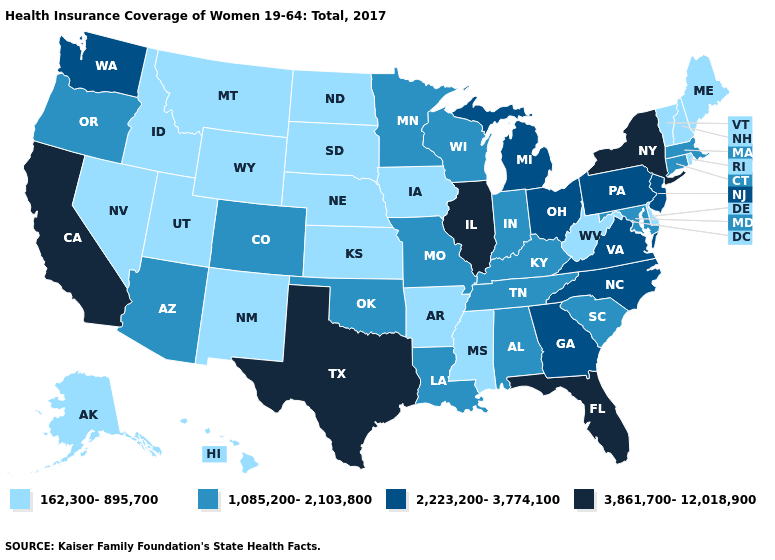What is the value of Iowa?
Give a very brief answer. 162,300-895,700. Name the states that have a value in the range 162,300-895,700?
Keep it brief. Alaska, Arkansas, Delaware, Hawaii, Idaho, Iowa, Kansas, Maine, Mississippi, Montana, Nebraska, Nevada, New Hampshire, New Mexico, North Dakota, Rhode Island, South Dakota, Utah, Vermont, West Virginia, Wyoming. Name the states that have a value in the range 2,223,200-3,774,100?
Be succinct. Georgia, Michigan, New Jersey, North Carolina, Ohio, Pennsylvania, Virginia, Washington. Name the states that have a value in the range 2,223,200-3,774,100?
Concise answer only. Georgia, Michigan, New Jersey, North Carolina, Ohio, Pennsylvania, Virginia, Washington. How many symbols are there in the legend?
Answer briefly. 4. Which states have the lowest value in the Northeast?
Write a very short answer. Maine, New Hampshire, Rhode Island, Vermont. Name the states that have a value in the range 1,085,200-2,103,800?
Keep it brief. Alabama, Arizona, Colorado, Connecticut, Indiana, Kentucky, Louisiana, Maryland, Massachusetts, Minnesota, Missouri, Oklahoma, Oregon, South Carolina, Tennessee, Wisconsin. What is the value of Kentucky?
Quick response, please. 1,085,200-2,103,800. What is the highest value in the USA?
Write a very short answer. 3,861,700-12,018,900. Name the states that have a value in the range 2,223,200-3,774,100?
Quick response, please. Georgia, Michigan, New Jersey, North Carolina, Ohio, Pennsylvania, Virginia, Washington. What is the lowest value in the USA?
Quick response, please. 162,300-895,700. Among the states that border Missouri , which have the highest value?
Give a very brief answer. Illinois. Does New York have the highest value in the USA?
Concise answer only. Yes. Which states have the lowest value in the MidWest?
Write a very short answer. Iowa, Kansas, Nebraska, North Dakota, South Dakota. Does Oklahoma have the same value as Indiana?
Short answer required. Yes. 